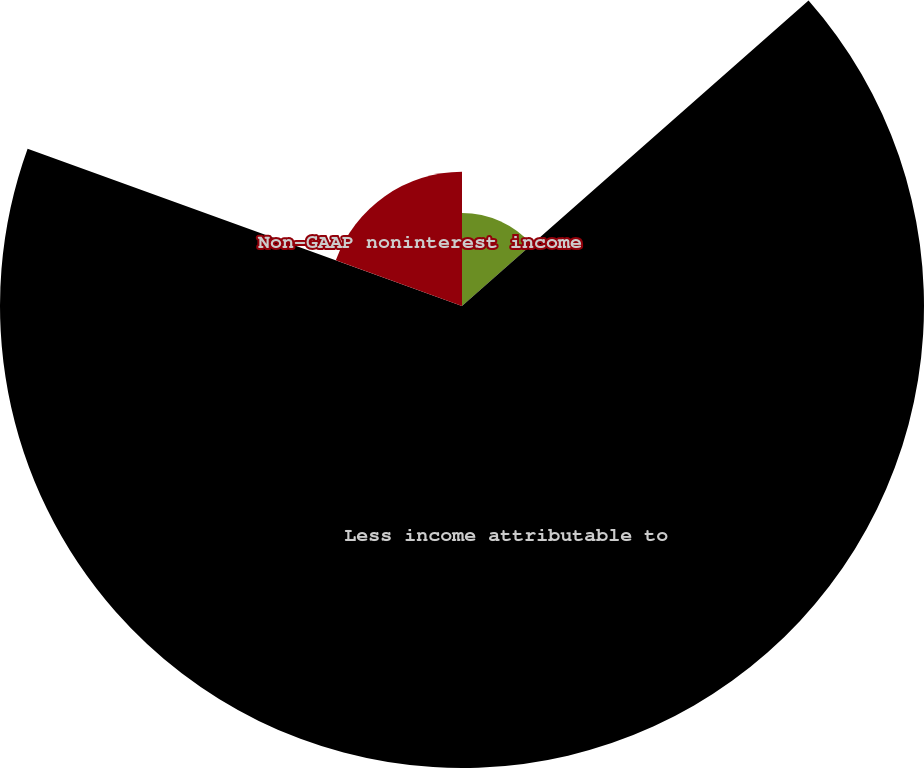<chart> <loc_0><loc_0><loc_500><loc_500><pie_chart><fcel>GAAP noninterest income<fcel>Less income attributable to<fcel>Non-GAAP noninterest income<nl><fcel>13.5%<fcel>67.03%<fcel>19.47%<nl></chart> 